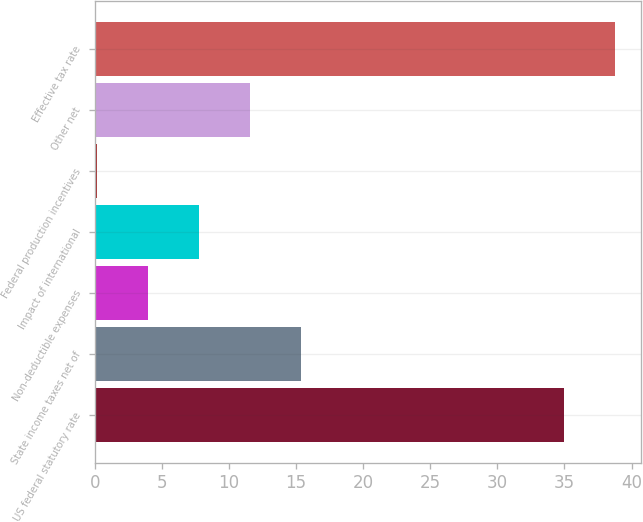Convert chart to OTSL. <chart><loc_0><loc_0><loc_500><loc_500><bar_chart><fcel>US federal statutory rate<fcel>State income taxes net of<fcel>Non-deductible expenses<fcel>Impact of international<fcel>Federal production incentives<fcel>Other net<fcel>Effective tax rate<nl><fcel>35<fcel>15.36<fcel>3.99<fcel>7.78<fcel>0.2<fcel>11.57<fcel>38.79<nl></chart> 